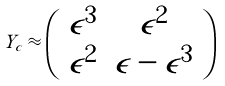<formula> <loc_0><loc_0><loc_500><loc_500>Y _ { c } \approx \left ( \begin{array} { c c } \epsilon ^ { 3 } & \epsilon ^ { 2 } \\ \epsilon ^ { 2 } & \epsilon - \epsilon ^ { 3 } \end{array} \right )</formula> 